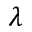Convert formula to latex. <formula><loc_0><loc_0><loc_500><loc_500>\lambda</formula> 